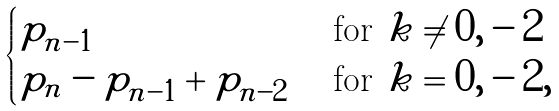Convert formula to latex. <formula><loc_0><loc_0><loc_500><loc_500>\begin{cases} p _ { n - 1 } & \text { for } k \neq 0 , - 2 \\ p _ { n } - p _ { n - 1 } + p _ { n - 2 } & \text { for } k = 0 , - 2 , \end{cases}</formula> 